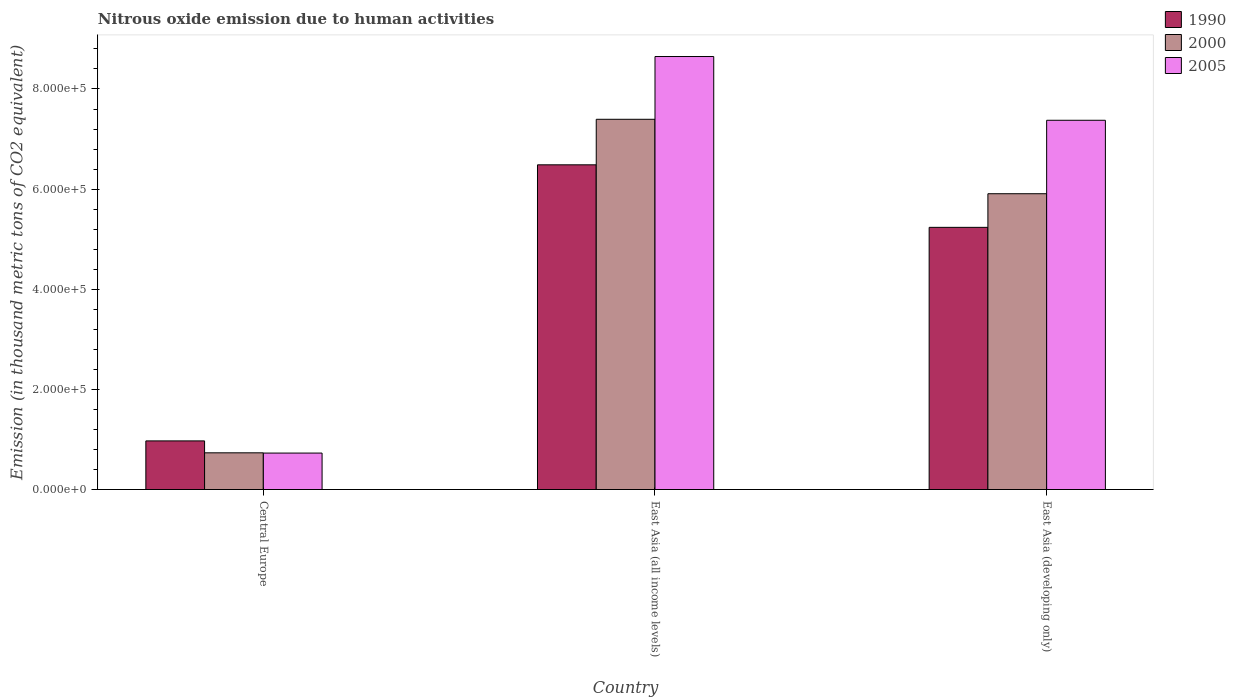How many different coloured bars are there?
Your answer should be very brief. 3. Are the number of bars per tick equal to the number of legend labels?
Your response must be concise. Yes. Are the number of bars on each tick of the X-axis equal?
Provide a succinct answer. Yes. What is the label of the 3rd group of bars from the left?
Keep it short and to the point. East Asia (developing only). In how many cases, is the number of bars for a given country not equal to the number of legend labels?
Provide a short and direct response. 0. What is the amount of nitrous oxide emitted in 1990 in Central Europe?
Offer a terse response. 9.71e+04. Across all countries, what is the maximum amount of nitrous oxide emitted in 2000?
Your response must be concise. 7.39e+05. Across all countries, what is the minimum amount of nitrous oxide emitted in 1990?
Your answer should be very brief. 9.71e+04. In which country was the amount of nitrous oxide emitted in 2000 maximum?
Provide a succinct answer. East Asia (all income levels). In which country was the amount of nitrous oxide emitted in 2005 minimum?
Your response must be concise. Central Europe. What is the total amount of nitrous oxide emitted in 2005 in the graph?
Offer a terse response. 1.68e+06. What is the difference between the amount of nitrous oxide emitted in 2000 in East Asia (all income levels) and that in East Asia (developing only)?
Give a very brief answer. 1.49e+05. What is the difference between the amount of nitrous oxide emitted in 2005 in Central Europe and the amount of nitrous oxide emitted in 2000 in East Asia (all income levels)?
Your response must be concise. -6.67e+05. What is the average amount of nitrous oxide emitted in 2005 per country?
Provide a succinct answer. 5.58e+05. What is the difference between the amount of nitrous oxide emitted of/in 2005 and amount of nitrous oxide emitted of/in 1990 in Central Europe?
Provide a succinct answer. -2.43e+04. What is the ratio of the amount of nitrous oxide emitted in 2000 in Central Europe to that in East Asia (all income levels)?
Offer a very short reply. 0.1. Is the difference between the amount of nitrous oxide emitted in 2005 in Central Europe and East Asia (all income levels) greater than the difference between the amount of nitrous oxide emitted in 1990 in Central Europe and East Asia (all income levels)?
Make the answer very short. No. What is the difference between the highest and the second highest amount of nitrous oxide emitted in 2005?
Offer a terse response. 7.92e+05. What is the difference between the highest and the lowest amount of nitrous oxide emitted in 1990?
Offer a very short reply. 5.51e+05. Is the sum of the amount of nitrous oxide emitted in 2005 in Central Europe and East Asia (all income levels) greater than the maximum amount of nitrous oxide emitted in 1990 across all countries?
Offer a very short reply. Yes. What does the 1st bar from the right in Central Europe represents?
Provide a succinct answer. 2005. Is it the case that in every country, the sum of the amount of nitrous oxide emitted in 2005 and amount of nitrous oxide emitted in 2000 is greater than the amount of nitrous oxide emitted in 1990?
Your response must be concise. Yes. How many bars are there?
Provide a short and direct response. 9. Are all the bars in the graph horizontal?
Keep it short and to the point. No. How many countries are there in the graph?
Ensure brevity in your answer.  3. What is the difference between two consecutive major ticks on the Y-axis?
Provide a short and direct response. 2.00e+05. Are the values on the major ticks of Y-axis written in scientific E-notation?
Keep it short and to the point. Yes. What is the title of the graph?
Offer a terse response. Nitrous oxide emission due to human activities. Does "1981" appear as one of the legend labels in the graph?
Make the answer very short. No. What is the label or title of the X-axis?
Make the answer very short. Country. What is the label or title of the Y-axis?
Your answer should be compact. Emission (in thousand metric tons of CO2 equivalent). What is the Emission (in thousand metric tons of CO2 equivalent) of 1990 in Central Europe?
Make the answer very short. 9.71e+04. What is the Emission (in thousand metric tons of CO2 equivalent) in 2000 in Central Europe?
Make the answer very short. 7.33e+04. What is the Emission (in thousand metric tons of CO2 equivalent) in 2005 in Central Europe?
Your answer should be very brief. 7.28e+04. What is the Emission (in thousand metric tons of CO2 equivalent) in 1990 in East Asia (all income levels)?
Give a very brief answer. 6.49e+05. What is the Emission (in thousand metric tons of CO2 equivalent) of 2000 in East Asia (all income levels)?
Your answer should be very brief. 7.39e+05. What is the Emission (in thousand metric tons of CO2 equivalent) in 2005 in East Asia (all income levels)?
Offer a terse response. 8.65e+05. What is the Emission (in thousand metric tons of CO2 equivalent) of 1990 in East Asia (developing only)?
Provide a succinct answer. 5.24e+05. What is the Emission (in thousand metric tons of CO2 equivalent) in 2000 in East Asia (developing only)?
Your response must be concise. 5.91e+05. What is the Emission (in thousand metric tons of CO2 equivalent) in 2005 in East Asia (developing only)?
Ensure brevity in your answer.  7.38e+05. Across all countries, what is the maximum Emission (in thousand metric tons of CO2 equivalent) in 1990?
Give a very brief answer. 6.49e+05. Across all countries, what is the maximum Emission (in thousand metric tons of CO2 equivalent) in 2000?
Provide a short and direct response. 7.39e+05. Across all countries, what is the maximum Emission (in thousand metric tons of CO2 equivalent) in 2005?
Your answer should be compact. 8.65e+05. Across all countries, what is the minimum Emission (in thousand metric tons of CO2 equivalent) in 1990?
Provide a succinct answer. 9.71e+04. Across all countries, what is the minimum Emission (in thousand metric tons of CO2 equivalent) of 2000?
Offer a terse response. 7.33e+04. Across all countries, what is the minimum Emission (in thousand metric tons of CO2 equivalent) in 2005?
Offer a very short reply. 7.28e+04. What is the total Emission (in thousand metric tons of CO2 equivalent) of 1990 in the graph?
Your response must be concise. 1.27e+06. What is the total Emission (in thousand metric tons of CO2 equivalent) of 2000 in the graph?
Offer a very short reply. 1.40e+06. What is the total Emission (in thousand metric tons of CO2 equivalent) in 2005 in the graph?
Keep it short and to the point. 1.68e+06. What is the difference between the Emission (in thousand metric tons of CO2 equivalent) of 1990 in Central Europe and that in East Asia (all income levels)?
Your response must be concise. -5.51e+05. What is the difference between the Emission (in thousand metric tons of CO2 equivalent) of 2000 in Central Europe and that in East Asia (all income levels)?
Offer a very short reply. -6.66e+05. What is the difference between the Emission (in thousand metric tons of CO2 equivalent) in 2005 in Central Europe and that in East Asia (all income levels)?
Offer a very short reply. -7.92e+05. What is the difference between the Emission (in thousand metric tons of CO2 equivalent) in 1990 in Central Europe and that in East Asia (developing only)?
Provide a succinct answer. -4.27e+05. What is the difference between the Emission (in thousand metric tons of CO2 equivalent) in 2000 in Central Europe and that in East Asia (developing only)?
Offer a terse response. -5.17e+05. What is the difference between the Emission (in thousand metric tons of CO2 equivalent) of 2005 in Central Europe and that in East Asia (developing only)?
Provide a succinct answer. -6.65e+05. What is the difference between the Emission (in thousand metric tons of CO2 equivalent) in 1990 in East Asia (all income levels) and that in East Asia (developing only)?
Give a very brief answer. 1.25e+05. What is the difference between the Emission (in thousand metric tons of CO2 equivalent) in 2000 in East Asia (all income levels) and that in East Asia (developing only)?
Ensure brevity in your answer.  1.49e+05. What is the difference between the Emission (in thousand metric tons of CO2 equivalent) in 2005 in East Asia (all income levels) and that in East Asia (developing only)?
Ensure brevity in your answer.  1.27e+05. What is the difference between the Emission (in thousand metric tons of CO2 equivalent) of 1990 in Central Europe and the Emission (in thousand metric tons of CO2 equivalent) of 2000 in East Asia (all income levels)?
Your answer should be compact. -6.42e+05. What is the difference between the Emission (in thousand metric tons of CO2 equivalent) of 1990 in Central Europe and the Emission (in thousand metric tons of CO2 equivalent) of 2005 in East Asia (all income levels)?
Provide a short and direct response. -7.68e+05. What is the difference between the Emission (in thousand metric tons of CO2 equivalent) in 2000 in Central Europe and the Emission (in thousand metric tons of CO2 equivalent) in 2005 in East Asia (all income levels)?
Ensure brevity in your answer.  -7.92e+05. What is the difference between the Emission (in thousand metric tons of CO2 equivalent) of 1990 in Central Europe and the Emission (in thousand metric tons of CO2 equivalent) of 2000 in East Asia (developing only)?
Make the answer very short. -4.94e+05. What is the difference between the Emission (in thousand metric tons of CO2 equivalent) in 1990 in Central Europe and the Emission (in thousand metric tons of CO2 equivalent) in 2005 in East Asia (developing only)?
Your response must be concise. -6.40e+05. What is the difference between the Emission (in thousand metric tons of CO2 equivalent) of 2000 in Central Europe and the Emission (in thousand metric tons of CO2 equivalent) of 2005 in East Asia (developing only)?
Provide a short and direct response. -6.64e+05. What is the difference between the Emission (in thousand metric tons of CO2 equivalent) of 1990 in East Asia (all income levels) and the Emission (in thousand metric tons of CO2 equivalent) of 2000 in East Asia (developing only)?
Offer a terse response. 5.78e+04. What is the difference between the Emission (in thousand metric tons of CO2 equivalent) of 1990 in East Asia (all income levels) and the Emission (in thousand metric tons of CO2 equivalent) of 2005 in East Asia (developing only)?
Your response must be concise. -8.90e+04. What is the difference between the Emission (in thousand metric tons of CO2 equivalent) in 2000 in East Asia (all income levels) and the Emission (in thousand metric tons of CO2 equivalent) in 2005 in East Asia (developing only)?
Offer a terse response. 1949.3. What is the average Emission (in thousand metric tons of CO2 equivalent) of 1990 per country?
Provide a short and direct response. 4.23e+05. What is the average Emission (in thousand metric tons of CO2 equivalent) of 2000 per country?
Make the answer very short. 4.68e+05. What is the average Emission (in thousand metric tons of CO2 equivalent) in 2005 per country?
Your answer should be very brief. 5.58e+05. What is the difference between the Emission (in thousand metric tons of CO2 equivalent) of 1990 and Emission (in thousand metric tons of CO2 equivalent) of 2000 in Central Europe?
Offer a very short reply. 2.38e+04. What is the difference between the Emission (in thousand metric tons of CO2 equivalent) of 1990 and Emission (in thousand metric tons of CO2 equivalent) of 2005 in Central Europe?
Give a very brief answer. 2.43e+04. What is the difference between the Emission (in thousand metric tons of CO2 equivalent) of 2000 and Emission (in thousand metric tons of CO2 equivalent) of 2005 in Central Europe?
Your response must be concise. 496.7. What is the difference between the Emission (in thousand metric tons of CO2 equivalent) in 1990 and Emission (in thousand metric tons of CO2 equivalent) in 2000 in East Asia (all income levels)?
Your response must be concise. -9.09e+04. What is the difference between the Emission (in thousand metric tons of CO2 equivalent) in 1990 and Emission (in thousand metric tons of CO2 equivalent) in 2005 in East Asia (all income levels)?
Ensure brevity in your answer.  -2.16e+05. What is the difference between the Emission (in thousand metric tons of CO2 equivalent) of 2000 and Emission (in thousand metric tons of CO2 equivalent) of 2005 in East Asia (all income levels)?
Make the answer very short. -1.25e+05. What is the difference between the Emission (in thousand metric tons of CO2 equivalent) of 1990 and Emission (in thousand metric tons of CO2 equivalent) of 2000 in East Asia (developing only)?
Your answer should be compact. -6.71e+04. What is the difference between the Emission (in thousand metric tons of CO2 equivalent) of 1990 and Emission (in thousand metric tons of CO2 equivalent) of 2005 in East Asia (developing only)?
Offer a terse response. -2.14e+05. What is the difference between the Emission (in thousand metric tons of CO2 equivalent) of 2000 and Emission (in thousand metric tons of CO2 equivalent) of 2005 in East Asia (developing only)?
Ensure brevity in your answer.  -1.47e+05. What is the ratio of the Emission (in thousand metric tons of CO2 equivalent) in 1990 in Central Europe to that in East Asia (all income levels)?
Ensure brevity in your answer.  0.15. What is the ratio of the Emission (in thousand metric tons of CO2 equivalent) of 2000 in Central Europe to that in East Asia (all income levels)?
Provide a succinct answer. 0.1. What is the ratio of the Emission (in thousand metric tons of CO2 equivalent) of 2005 in Central Europe to that in East Asia (all income levels)?
Give a very brief answer. 0.08. What is the ratio of the Emission (in thousand metric tons of CO2 equivalent) in 1990 in Central Europe to that in East Asia (developing only)?
Your answer should be very brief. 0.19. What is the ratio of the Emission (in thousand metric tons of CO2 equivalent) of 2000 in Central Europe to that in East Asia (developing only)?
Provide a succinct answer. 0.12. What is the ratio of the Emission (in thousand metric tons of CO2 equivalent) in 2005 in Central Europe to that in East Asia (developing only)?
Your answer should be very brief. 0.1. What is the ratio of the Emission (in thousand metric tons of CO2 equivalent) of 1990 in East Asia (all income levels) to that in East Asia (developing only)?
Make the answer very short. 1.24. What is the ratio of the Emission (in thousand metric tons of CO2 equivalent) in 2000 in East Asia (all income levels) to that in East Asia (developing only)?
Your response must be concise. 1.25. What is the ratio of the Emission (in thousand metric tons of CO2 equivalent) in 2005 in East Asia (all income levels) to that in East Asia (developing only)?
Give a very brief answer. 1.17. What is the difference between the highest and the second highest Emission (in thousand metric tons of CO2 equivalent) of 1990?
Give a very brief answer. 1.25e+05. What is the difference between the highest and the second highest Emission (in thousand metric tons of CO2 equivalent) of 2000?
Provide a succinct answer. 1.49e+05. What is the difference between the highest and the second highest Emission (in thousand metric tons of CO2 equivalent) in 2005?
Make the answer very short. 1.27e+05. What is the difference between the highest and the lowest Emission (in thousand metric tons of CO2 equivalent) of 1990?
Offer a very short reply. 5.51e+05. What is the difference between the highest and the lowest Emission (in thousand metric tons of CO2 equivalent) of 2000?
Provide a succinct answer. 6.66e+05. What is the difference between the highest and the lowest Emission (in thousand metric tons of CO2 equivalent) of 2005?
Give a very brief answer. 7.92e+05. 